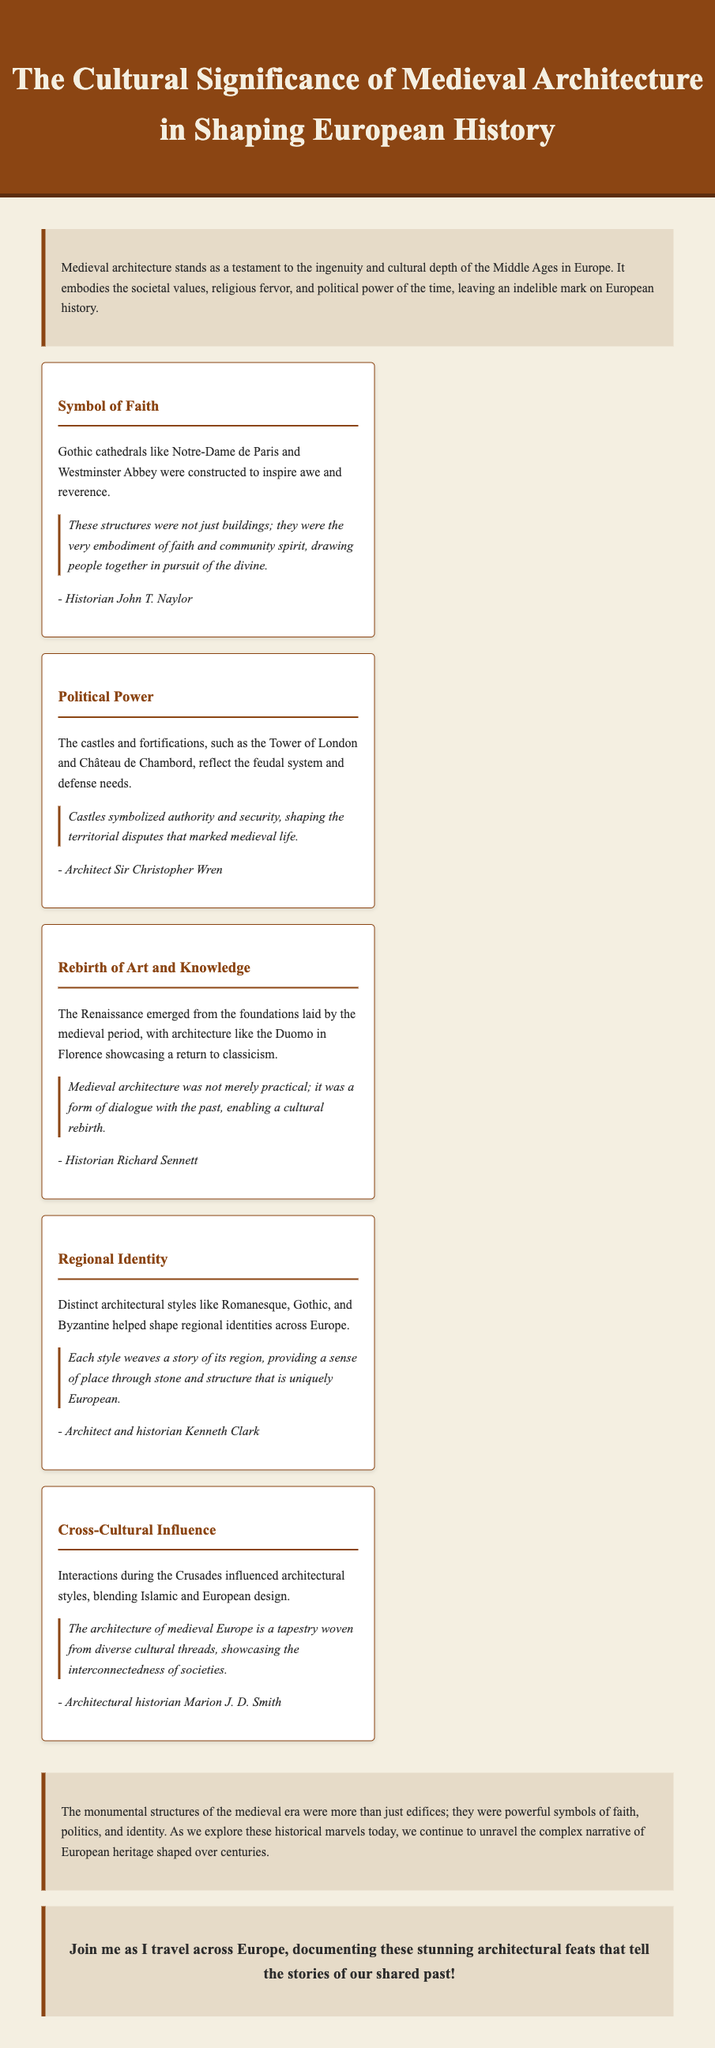what is the title of the blog post? The title of the blog post is prominently displayed in the header section of the document.
Answer: The Cultural Significance of Medieval Architecture in Shaping European History who is the author of the quote about Gothic cathedrals? The author of the quote about Gothic cathedrals is mentioned below the quote itself.
Answer: John T. Naylor what type of architecture reflects the feudal system and defense needs? The document specifies a type of architecture that embodies these characteristics in one of its key points.
Answer: Castles and fortifications which architect discusses the regional identity in architecture? The name of the architect discussing regional identity is provided after his quote on the unique European stories of each architectural style.
Answer: Kenneth Clark how many key points are discussed in the document? The number of key points can be counted from the key points section in the document.
Answer: Five 